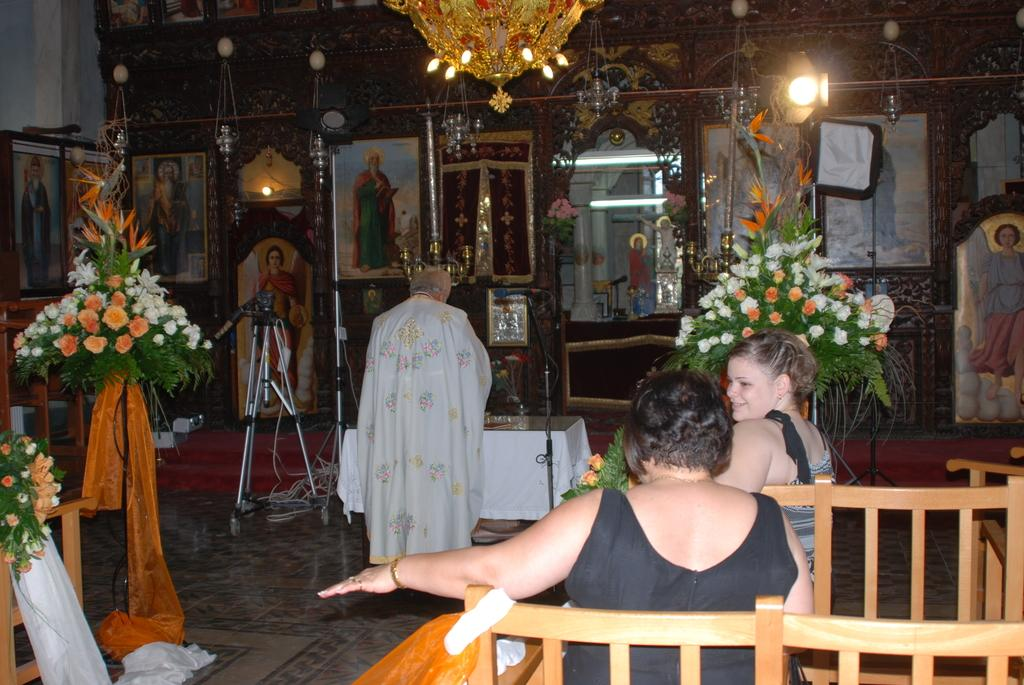What are the people in the image doing? People are sitting on a bench in the image. Is there anyone standing in the image? Yes, there is a man standing in the image. What can be seen on the wall in the image? There are photo frames on the wall in the image. Can you describe any natural elements in the image? Yes, there is a plant in the image. What type of grape is being used to decorate the bench in the image? There is no grape present in the image, and the bench is not decorated with grapes. What is the most efficient route to take from the bench to the plant in the image? The facts provided do not give enough information to determine the most efficient route between the bench and the plant. 